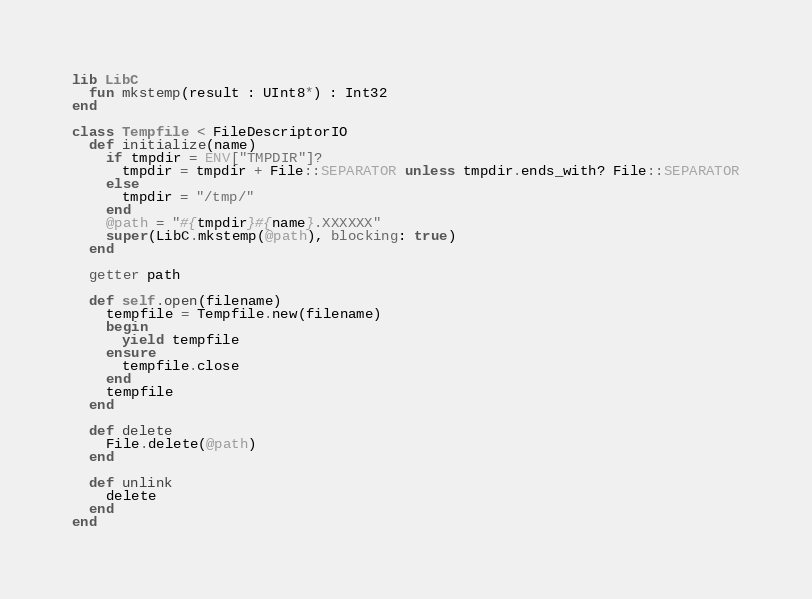Convert code to text. <code><loc_0><loc_0><loc_500><loc_500><_Crystal_>lib LibC
  fun mkstemp(result : UInt8*) : Int32
end

class Tempfile < FileDescriptorIO
  def initialize(name)
    if tmpdir = ENV["TMPDIR"]?
      tmpdir = tmpdir + File::SEPARATOR unless tmpdir.ends_with? File::SEPARATOR
    else
      tmpdir = "/tmp/"
    end
    @path = "#{tmpdir}#{name}.XXXXXX"
    super(LibC.mkstemp(@path), blocking: true)
  end

  getter path

  def self.open(filename)
    tempfile = Tempfile.new(filename)
    begin
      yield tempfile
    ensure
      tempfile.close
    end
    tempfile
  end

  def delete
    File.delete(@path)
  end

  def unlink
    delete
  end
end
</code> 